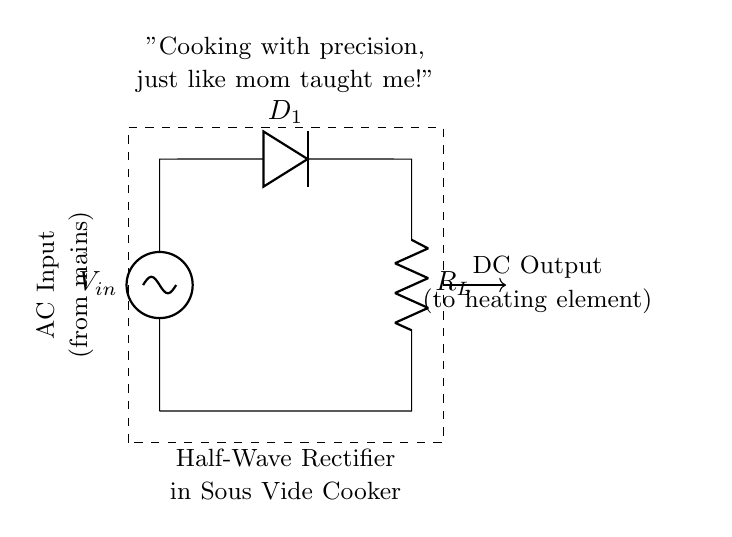What type of rectifier is shown in this circuit? The circuit is labeled as a "Half-Wave Rectifier," indicating that it only allows one half of the AC waveform to pass through and blocks the other half.
Answer: Half-Wave Rectifier What component is used to convert AC to DC? The circuit diagram includes a diode, labeled as D1. The diode is the component responsible for allowing current to flow in only one direction, which is essential for rectification.
Answer: Diode What is the role of the load resistor in this circuit? The load resistor, labeled R_L, provides a path for the current after the rectification process. It is essential for determining the output voltage and current delivered to the cooking element.
Answer: Load resistor From which source does the circuit get its input? The input voltage is labeled as V_in and is sourced from the AC mains, indicating that it receives alternating current from the electrical supply.
Answer: AC mains How many outputs does this circuit have? The circuit diagram indicates one output, labeled as the DC output, showing that it converts the AC input to a single DC output for the heating element.
Answer: One output What does 'DC Output' power in the sous vide cooker? The 'DC Output' is directed to the heating element. This output is the result of the rectification process and is used to provide a stable voltage for heating, essential in sous vide cooking.
Answer: Heating element 